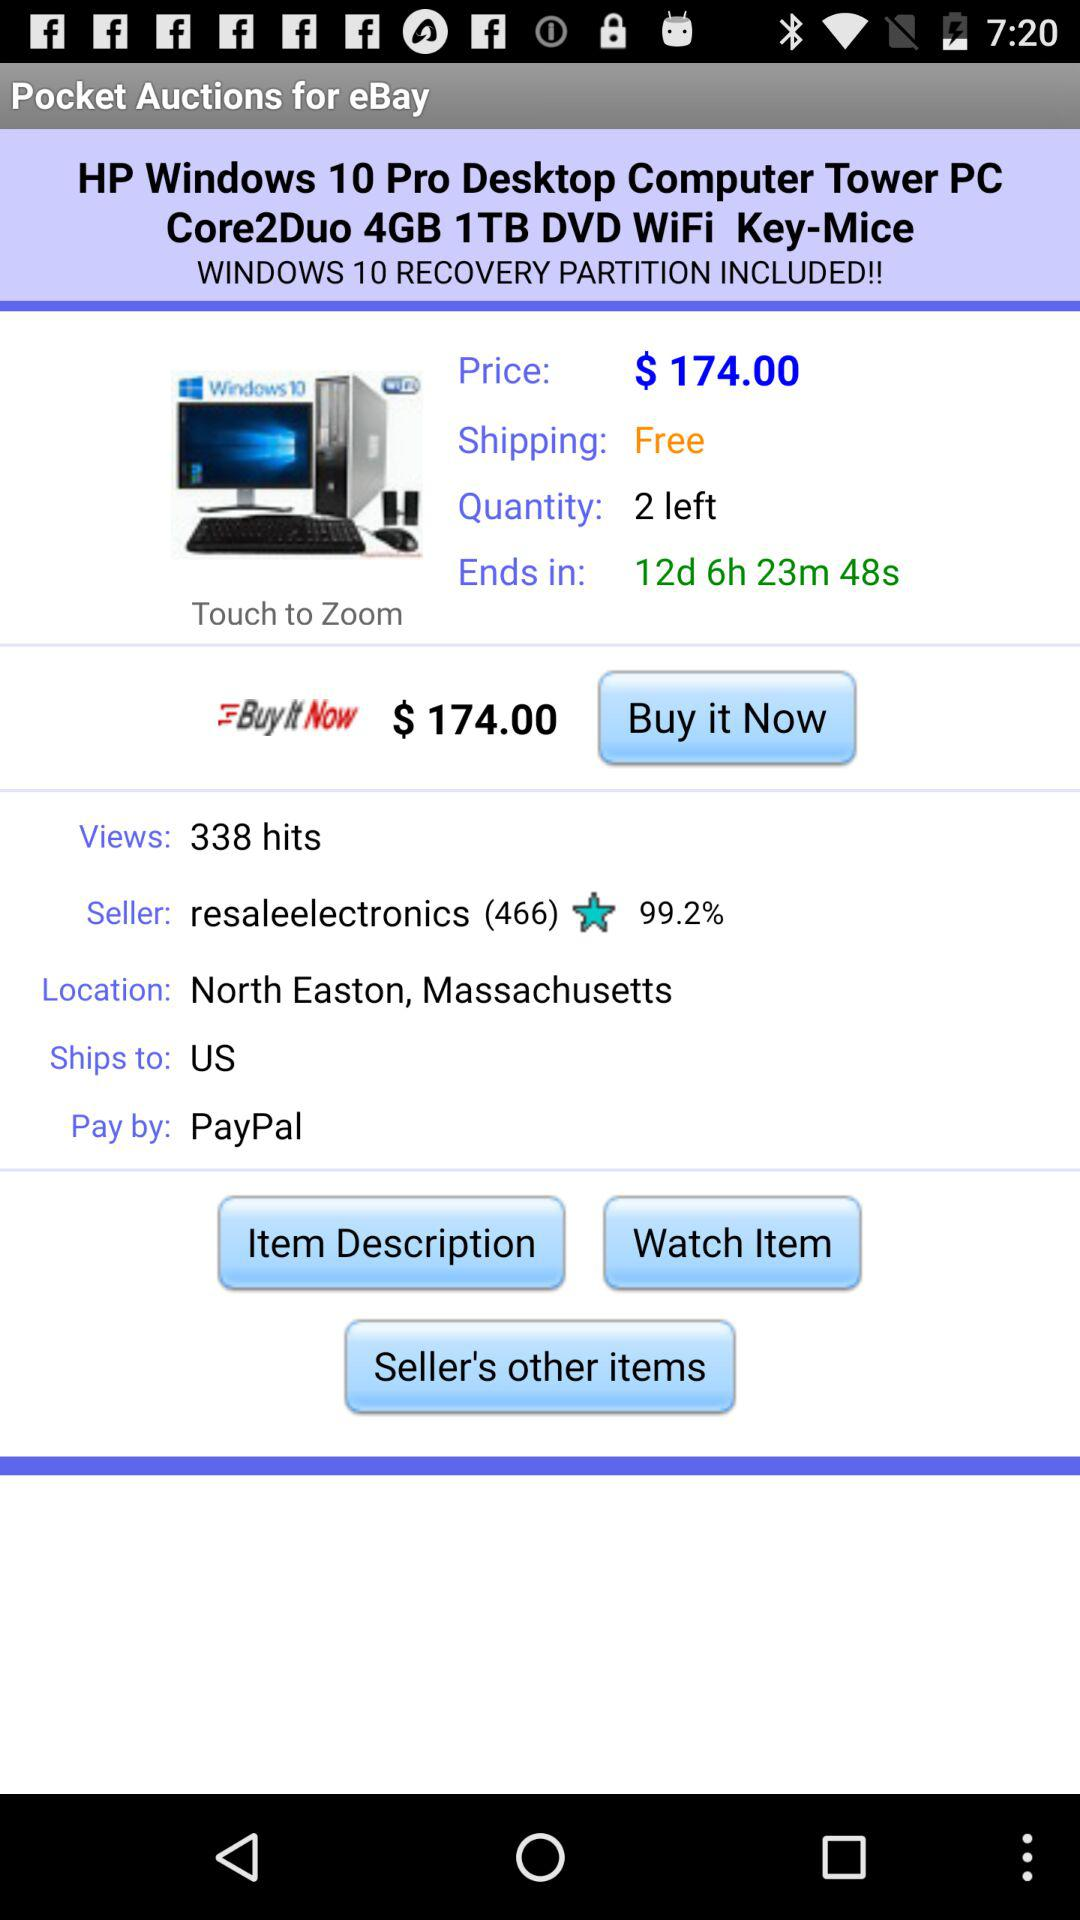How many "HP Windows 10 Pro Desktop Computer Tower PC" are left? There are 2 "HP Windows 10 Pro Desktop Computer Tower PC" left. 